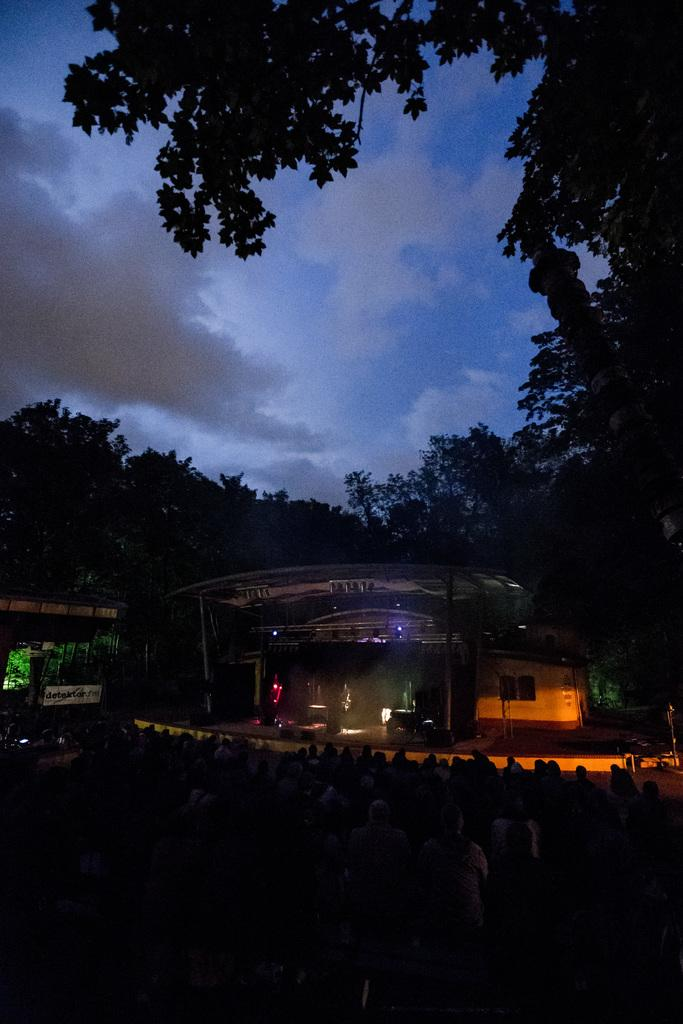What type of structure is visible in the image? There is a shed in the image. What natural elements can be seen in the image? There are many trees, plants, and grass visible in the image. What part of the sky is visible in the image? The sky is visible on the left side of the image. What atmospheric conditions can be observed in the sky? Clouds are present in the sky. What color is the eye of the person sitting on the sofa in the image? There is no person sitting on a sofa in the image; it features a shed, trees, plants, grass, and a sky with clouds. 